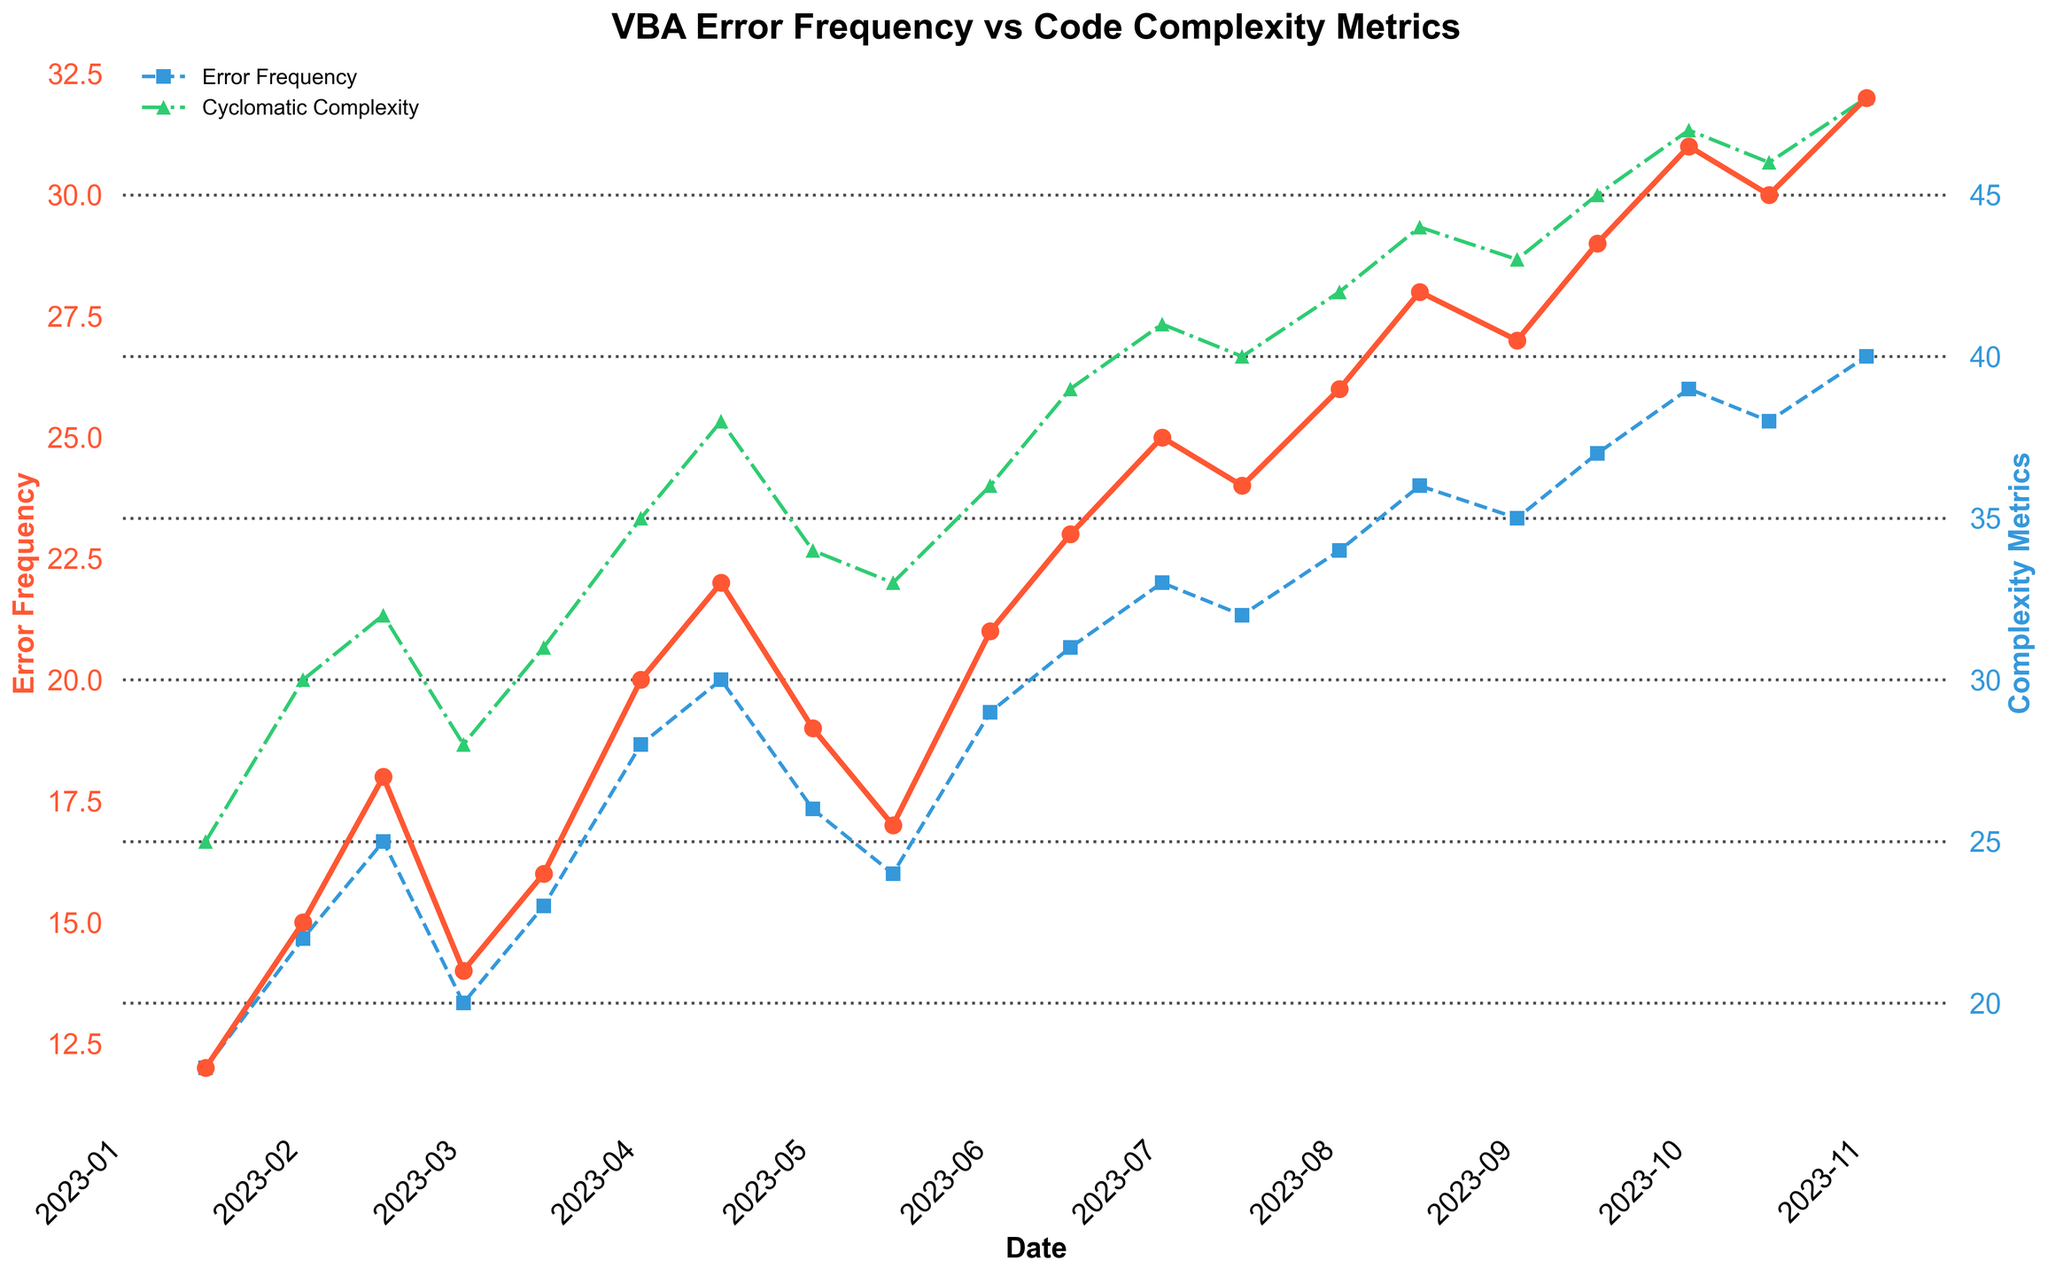What is the overall trend in Error Frequency over time? By examining the line plot for Error Frequency, it is apparent that the error frequency generally increases over time from January to November 2023. It starts at 12 in January and ends at 32 in November, with periodic fluctuations.
Answer: Increasing During which time period does Cyclomatic Complexity increase the most? Observing the line plot for Cyclomatic Complexity, the most significant increase appears between April 1st and April 15th. The Cyclomatic Complexity rises sharply from 28 to 30 during this period.
Answer: April 1st to April 15th How many time series are plotted in the figure, and what are their visual representations? Three time series are plotted in the figure: Error Frequency (red line with circles), Cyclomatic Complexity (blue dashed line with squares), and Function Count (green dash-dot line with triangles). Each series has distinct colors and markers to differentiate them.
Answer: Three; Error Frequency (red circles), Cyclomatic Complexity (blue squares), Function Count (green triangles) On which date does Function Count first reach the value of 40? By checking the green dash-dot line representing Function Count, it first reaches the value of 40 on July 1st, 2023.
Answer: July 1st, 2023 Comparing May 1st and September 15th, which date has higher Cyclomatic Complexity and by how much? On May 1st, the Cyclomatic Complexity is 26. On September 15th, it is 37. The difference is 37 - 26 = 11. Hence, September 15th has a higher Cyclomatic Complexity by 11 units.
Answer: September 15th by 11 Is there a date where both Cyclomatic Complexity and Function Count are at their respective maximums? Checking the peaks of both lines, Cyclomatic Complexity reaches its maximum at 40 on November 1st, whereas Function Count peaks at 48 on November 1st as well.
Answer: Yes, November 1st Is there a period where the Error Frequency decreases while at least one complexity metric increases? Notice the drop in Error Frequency from July 15th (24) to August 1st (26). During this period, the Function Count increases from 40 to 42, demonstrating that at least one complexity metric increased while the error frequency decreased.
Answer: Yes, from July 15th to August 1st What is the error frequency on the date with the highest lines of code? The highest Lines of Code, 920, are on November 1st, where the Error Frequency is 32.
Answer: 32 Calculate the average Function Count for June 2023. The Function Count values for June 2023 are 36 on June 1st and 39 on June 15th. The average is (36 + 39) / 2 = 37.5.
Answer: 37.5 Which date shows the largest single-day increase in Error Frequency? The largest single-day increase in Error Frequency is from April 1st (20) to April 15th (22), an increase of 2.
Answer: April 1st to April 15th 